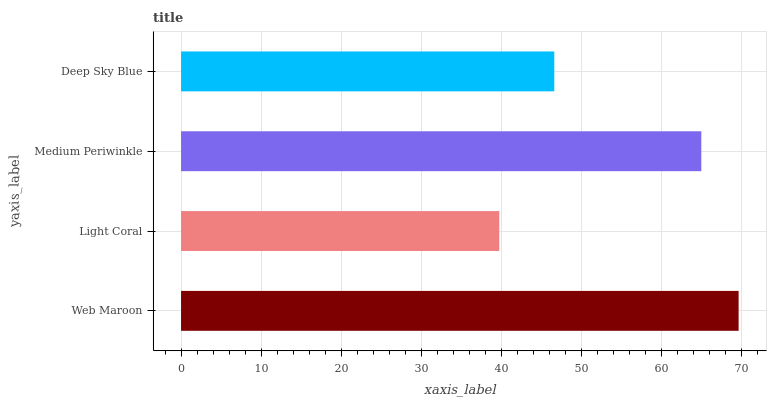Is Light Coral the minimum?
Answer yes or no. Yes. Is Web Maroon the maximum?
Answer yes or no. Yes. Is Medium Periwinkle the minimum?
Answer yes or no. No. Is Medium Periwinkle the maximum?
Answer yes or no. No. Is Medium Periwinkle greater than Light Coral?
Answer yes or no. Yes. Is Light Coral less than Medium Periwinkle?
Answer yes or no. Yes. Is Light Coral greater than Medium Periwinkle?
Answer yes or no. No. Is Medium Periwinkle less than Light Coral?
Answer yes or no. No. Is Medium Periwinkle the high median?
Answer yes or no. Yes. Is Deep Sky Blue the low median?
Answer yes or no. Yes. Is Deep Sky Blue the high median?
Answer yes or no. No. Is Medium Periwinkle the low median?
Answer yes or no. No. 